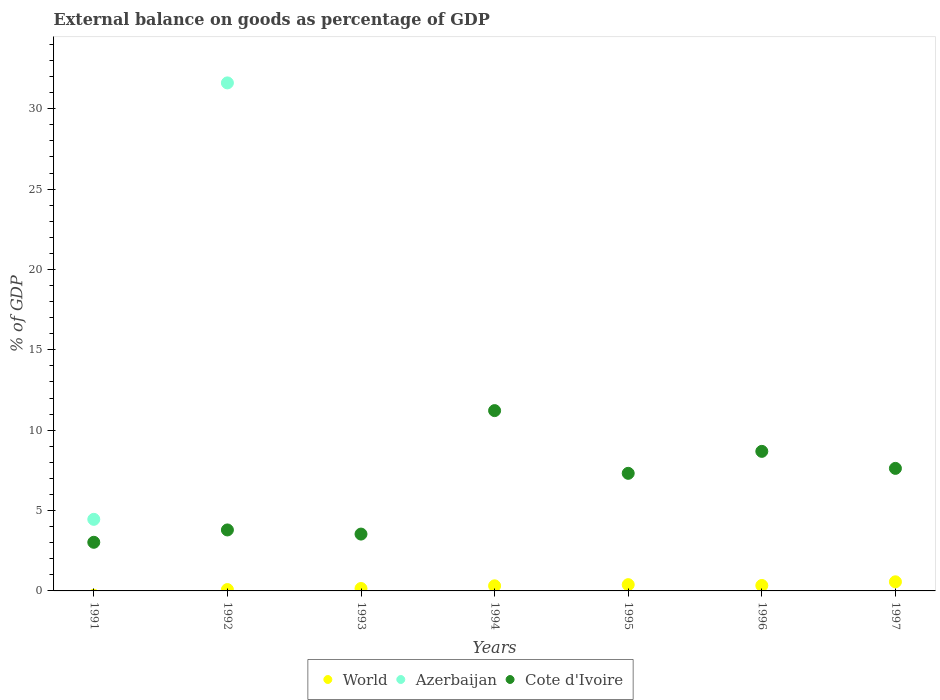What is the external balance on goods as percentage of GDP in Cote d'Ivoire in 1992?
Provide a succinct answer. 3.79. Across all years, what is the maximum external balance on goods as percentage of GDP in Cote d'Ivoire?
Give a very brief answer. 11.22. Across all years, what is the minimum external balance on goods as percentage of GDP in World?
Provide a succinct answer. 0. What is the total external balance on goods as percentage of GDP in World in the graph?
Provide a short and direct response. 1.85. What is the difference between the external balance on goods as percentage of GDP in Cote d'Ivoire in 1993 and that in 1996?
Keep it short and to the point. -5.15. What is the difference between the external balance on goods as percentage of GDP in Azerbaijan in 1994 and the external balance on goods as percentage of GDP in Cote d'Ivoire in 1997?
Make the answer very short. -7.62. What is the average external balance on goods as percentage of GDP in World per year?
Provide a short and direct response. 0.26. In the year 1992, what is the difference between the external balance on goods as percentage of GDP in Azerbaijan and external balance on goods as percentage of GDP in Cote d'Ivoire?
Your answer should be very brief. 27.81. In how many years, is the external balance on goods as percentage of GDP in Cote d'Ivoire greater than 30 %?
Ensure brevity in your answer.  0. What is the ratio of the external balance on goods as percentage of GDP in World in 1996 to that in 1997?
Keep it short and to the point. 0.6. What is the difference between the highest and the second highest external balance on goods as percentage of GDP in World?
Ensure brevity in your answer.  0.18. What is the difference between the highest and the lowest external balance on goods as percentage of GDP in Azerbaijan?
Offer a terse response. 31.61. Is the sum of the external balance on goods as percentage of GDP in World in 1993 and 1997 greater than the maximum external balance on goods as percentage of GDP in Azerbaijan across all years?
Ensure brevity in your answer.  No. Is it the case that in every year, the sum of the external balance on goods as percentage of GDP in Cote d'Ivoire and external balance on goods as percentage of GDP in Azerbaijan  is greater than the external balance on goods as percentage of GDP in World?
Give a very brief answer. Yes. Does the external balance on goods as percentage of GDP in Azerbaijan monotonically increase over the years?
Provide a succinct answer. No. Is the external balance on goods as percentage of GDP in Azerbaijan strictly greater than the external balance on goods as percentage of GDP in Cote d'Ivoire over the years?
Make the answer very short. No. Is the external balance on goods as percentage of GDP in World strictly less than the external balance on goods as percentage of GDP in Azerbaijan over the years?
Give a very brief answer. No. What is the difference between two consecutive major ticks on the Y-axis?
Keep it short and to the point. 5. Are the values on the major ticks of Y-axis written in scientific E-notation?
Give a very brief answer. No. Does the graph contain any zero values?
Give a very brief answer. Yes. Does the graph contain grids?
Your answer should be very brief. No. Where does the legend appear in the graph?
Provide a succinct answer. Bottom center. What is the title of the graph?
Give a very brief answer. External balance on goods as percentage of GDP. What is the label or title of the X-axis?
Your answer should be compact. Years. What is the label or title of the Y-axis?
Offer a terse response. % of GDP. What is the % of GDP of Azerbaijan in 1991?
Give a very brief answer. 4.45. What is the % of GDP in Cote d'Ivoire in 1991?
Ensure brevity in your answer.  3.03. What is the % of GDP in World in 1992?
Ensure brevity in your answer.  0.08. What is the % of GDP of Azerbaijan in 1992?
Provide a succinct answer. 31.61. What is the % of GDP in Cote d'Ivoire in 1992?
Your response must be concise. 3.79. What is the % of GDP in World in 1993?
Your answer should be very brief. 0.15. What is the % of GDP in Cote d'Ivoire in 1993?
Provide a succinct answer. 3.54. What is the % of GDP in World in 1994?
Provide a short and direct response. 0.32. What is the % of GDP in Cote d'Ivoire in 1994?
Your answer should be very brief. 11.22. What is the % of GDP of World in 1995?
Make the answer very short. 0.39. What is the % of GDP of Azerbaijan in 1995?
Offer a terse response. 0. What is the % of GDP in Cote d'Ivoire in 1995?
Offer a terse response. 7.32. What is the % of GDP in World in 1996?
Ensure brevity in your answer.  0.34. What is the % of GDP in Azerbaijan in 1996?
Provide a short and direct response. 0. What is the % of GDP of Cote d'Ivoire in 1996?
Your response must be concise. 8.68. What is the % of GDP of World in 1997?
Your answer should be compact. 0.57. What is the % of GDP in Azerbaijan in 1997?
Offer a very short reply. 0. What is the % of GDP of Cote d'Ivoire in 1997?
Provide a succinct answer. 7.62. Across all years, what is the maximum % of GDP in World?
Make the answer very short. 0.57. Across all years, what is the maximum % of GDP of Azerbaijan?
Offer a very short reply. 31.61. Across all years, what is the maximum % of GDP of Cote d'Ivoire?
Give a very brief answer. 11.22. Across all years, what is the minimum % of GDP in Cote d'Ivoire?
Offer a very short reply. 3.03. What is the total % of GDP of World in the graph?
Your response must be concise. 1.85. What is the total % of GDP in Azerbaijan in the graph?
Your answer should be very brief. 36.06. What is the total % of GDP of Cote d'Ivoire in the graph?
Offer a terse response. 45.2. What is the difference between the % of GDP of Azerbaijan in 1991 and that in 1992?
Offer a very short reply. -27.15. What is the difference between the % of GDP of Cote d'Ivoire in 1991 and that in 1992?
Your answer should be very brief. -0.77. What is the difference between the % of GDP of Cote d'Ivoire in 1991 and that in 1993?
Your answer should be compact. -0.51. What is the difference between the % of GDP in Cote d'Ivoire in 1991 and that in 1994?
Provide a succinct answer. -8.19. What is the difference between the % of GDP in Cote d'Ivoire in 1991 and that in 1995?
Keep it short and to the point. -4.29. What is the difference between the % of GDP in Cote d'Ivoire in 1991 and that in 1996?
Your answer should be compact. -5.66. What is the difference between the % of GDP of Cote d'Ivoire in 1991 and that in 1997?
Your answer should be very brief. -4.6. What is the difference between the % of GDP of World in 1992 and that in 1993?
Your response must be concise. -0.07. What is the difference between the % of GDP in Cote d'Ivoire in 1992 and that in 1993?
Give a very brief answer. 0.26. What is the difference between the % of GDP in World in 1992 and that in 1994?
Make the answer very short. -0.23. What is the difference between the % of GDP in Cote d'Ivoire in 1992 and that in 1994?
Your response must be concise. -7.42. What is the difference between the % of GDP in World in 1992 and that in 1995?
Your answer should be very brief. -0.31. What is the difference between the % of GDP in Cote d'Ivoire in 1992 and that in 1995?
Offer a very short reply. -3.52. What is the difference between the % of GDP of World in 1992 and that in 1996?
Offer a terse response. -0.25. What is the difference between the % of GDP of Cote d'Ivoire in 1992 and that in 1996?
Make the answer very short. -4.89. What is the difference between the % of GDP of World in 1992 and that in 1997?
Provide a succinct answer. -0.48. What is the difference between the % of GDP in Cote d'Ivoire in 1992 and that in 1997?
Your answer should be compact. -3.83. What is the difference between the % of GDP in World in 1993 and that in 1994?
Your answer should be compact. -0.17. What is the difference between the % of GDP of Cote d'Ivoire in 1993 and that in 1994?
Your response must be concise. -7.68. What is the difference between the % of GDP in World in 1993 and that in 1995?
Make the answer very short. -0.24. What is the difference between the % of GDP in Cote d'Ivoire in 1993 and that in 1995?
Make the answer very short. -3.78. What is the difference between the % of GDP of World in 1993 and that in 1996?
Your answer should be very brief. -0.19. What is the difference between the % of GDP in Cote d'Ivoire in 1993 and that in 1996?
Make the answer very short. -5.15. What is the difference between the % of GDP in World in 1993 and that in 1997?
Offer a very short reply. -0.42. What is the difference between the % of GDP in Cote d'Ivoire in 1993 and that in 1997?
Offer a terse response. -4.09. What is the difference between the % of GDP in World in 1994 and that in 1995?
Give a very brief answer. -0.07. What is the difference between the % of GDP of Cote d'Ivoire in 1994 and that in 1995?
Give a very brief answer. 3.9. What is the difference between the % of GDP of World in 1994 and that in 1996?
Ensure brevity in your answer.  -0.02. What is the difference between the % of GDP in Cote d'Ivoire in 1994 and that in 1996?
Provide a succinct answer. 2.54. What is the difference between the % of GDP of World in 1994 and that in 1997?
Keep it short and to the point. -0.25. What is the difference between the % of GDP of Cote d'Ivoire in 1994 and that in 1997?
Offer a very short reply. 3.59. What is the difference between the % of GDP in World in 1995 and that in 1996?
Offer a very short reply. 0.05. What is the difference between the % of GDP of Cote d'Ivoire in 1995 and that in 1996?
Make the answer very short. -1.37. What is the difference between the % of GDP in World in 1995 and that in 1997?
Offer a terse response. -0.18. What is the difference between the % of GDP in Cote d'Ivoire in 1995 and that in 1997?
Offer a very short reply. -0.31. What is the difference between the % of GDP of World in 1996 and that in 1997?
Offer a very short reply. -0.23. What is the difference between the % of GDP in Cote d'Ivoire in 1996 and that in 1997?
Provide a short and direct response. 1.06. What is the difference between the % of GDP of Azerbaijan in 1991 and the % of GDP of Cote d'Ivoire in 1992?
Your answer should be very brief. 0.66. What is the difference between the % of GDP of Azerbaijan in 1991 and the % of GDP of Cote d'Ivoire in 1993?
Provide a succinct answer. 0.92. What is the difference between the % of GDP of Azerbaijan in 1991 and the % of GDP of Cote d'Ivoire in 1994?
Give a very brief answer. -6.76. What is the difference between the % of GDP in Azerbaijan in 1991 and the % of GDP in Cote d'Ivoire in 1995?
Provide a short and direct response. -2.86. What is the difference between the % of GDP of Azerbaijan in 1991 and the % of GDP of Cote d'Ivoire in 1996?
Offer a terse response. -4.23. What is the difference between the % of GDP in Azerbaijan in 1991 and the % of GDP in Cote d'Ivoire in 1997?
Provide a short and direct response. -3.17. What is the difference between the % of GDP of World in 1992 and the % of GDP of Cote d'Ivoire in 1993?
Provide a short and direct response. -3.45. What is the difference between the % of GDP in Azerbaijan in 1992 and the % of GDP in Cote d'Ivoire in 1993?
Your answer should be very brief. 28.07. What is the difference between the % of GDP of World in 1992 and the % of GDP of Cote d'Ivoire in 1994?
Provide a short and direct response. -11.13. What is the difference between the % of GDP of Azerbaijan in 1992 and the % of GDP of Cote d'Ivoire in 1994?
Provide a short and direct response. 20.39. What is the difference between the % of GDP in World in 1992 and the % of GDP in Cote d'Ivoire in 1995?
Ensure brevity in your answer.  -7.23. What is the difference between the % of GDP in Azerbaijan in 1992 and the % of GDP in Cote d'Ivoire in 1995?
Your answer should be very brief. 24.29. What is the difference between the % of GDP in World in 1992 and the % of GDP in Cote d'Ivoire in 1996?
Your answer should be very brief. -8.6. What is the difference between the % of GDP in Azerbaijan in 1992 and the % of GDP in Cote d'Ivoire in 1996?
Your response must be concise. 22.92. What is the difference between the % of GDP in World in 1992 and the % of GDP in Cote d'Ivoire in 1997?
Your answer should be very brief. -7.54. What is the difference between the % of GDP of Azerbaijan in 1992 and the % of GDP of Cote d'Ivoire in 1997?
Give a very brief answer. 23.98. What is the difference between the % of GDP in World in 1993 and the % of GDP in Cote d'Ivoire in 1994?
Make the answer very short. -11.07. What is the difference between the % of GDP in World in 1993 and the % of GDP in Cote d'Ivoire in 1995?
Ensure brevity in your answer.  -7.17. What is the difference between the % of GDP of World in 1993 and the % of GDP of Cote d'Ivoire in 1996?
Your response must be concise. -8.53. What is the difference between the % of GDP of World in 1993 and the % of GDP of Cote d'Ivoire in 1997?
Make the answer very short. -7.47. What is the difference between the % of GDP in World in 1994 and the % of GDP in Cote d'Ivoire in 1995?
Keep it short and to the point. -7. What is the difference between the % of GDP in World in 1994 and the % of GDP in Cote d'Ivoire in 1996?
Your response must be concise. -8.37. What is the difference between the % of GDP of World in 1994 and the % of GDP of Cote d'Ivoire in 1997?
Offer a very short reply. -7.31. What is the difference between the % of GDP of World in 1995 and the % of GDP of Cote d'Ivoire in 1996?
Keep it short and to the point. -8.29. What is the difference between the % of GDP of World in 1995 and the % of GDP of Cote d'Ivoire in 1997?
Give a very brief answer. -7.23. What is the difference between the % of GDP of World in 1996 and the % of GDP of Cote d'Ivoire in 1997?
Provide a succinct answer. -7.29. What is the average % of GDP of World per year?
Your answer should be very brief. 0.26. What is the average % of GDP in Azerbaijan per year?
Your answer should be very brief. 5.15. What is the average % of GDP in Cote d'Ivoire per year?
Give a very brief answer. 6.46. In the year 1991, what is the difference between the % of GDP of Azerbaijan and % of GDP of Cote d'Ivoire?
Your answer should be compact. 1.43. In the year 1992, what is the difference between the % of GDP of World and % of GDP of Azerbaijan?
Provide a succinct answer. -31.52. In the year 1992, what is the difference between the % of GDP in World and % of GDP in Cote d'Ivoire?
Make the answer very short. -3.71. In the year 1992, what is the difference between the % of GDP in Azerbaijan and % of GDP in Cote d'Ivoire?
Provide a short and direct response. 27.81. In the year 1993, what is the difference between the % of GDP of World and % of GDP of Cote d'Ivoire?
Make the answer very short. -3.39. In the year 1994, what is the difference between the % of GDP in World and % of GDP in Cote d'Ivoire?
Your response must be concise. -10.9. In the year 1995, what is the difference between the % of GDP in World and % of GDP in Cote d'Ivoire?
Your response must be concise. -6.93. In the year 1996, what is the difference between the % of GDP of World and % of GDP of Cote d'Ivoire?
Your answer should be very brief. -8.34. In the year 1997, what is the difference between the % of GDP in World and % of GDP in Cote d'Ivoire?
Make the answer very short. -7.06. What is the ratio of the % of GDP in Azerbaijan in 1991 to that in 1992?
Give a very brief answer. 0.14. What is the ratio of the % of GDP in Cote d'Ivoire in 1991 to that in 1992?
Give a very brief answer. 0.8. What is the ratio of the % of GDP in Cote d'Ivoire in 1991 to that in 1993?
Make the answer very short. 0.86. What is the ratio of the % of GDP in Cote d'Ivoire in 1991 to that in 1994?
Provide a succinct answer. 0.27. What is the ratio of the % of GDP in Cote d'Ivoire in 1991 to that in 1995?
Offer a very short reply. 0.41. What is the ratio of the % of GDP of Cote d'Ivoire in 1991 to that in 1996?
Make the answer very short. 0.35. What is the ratio of the % of GDP in Cote d'Ivoire in 1991 to that in 1997?
Your response must be concise. 0.4. What is the ratio of the % of GDP in World in 1992 to that in 1993?
Provide a succinct answer. 0.56. What is the ratio of the % of GDP of Cote d'Ivoire in 1992 to that in 1993?
Your response must be concise. 1.07. What is the ratio of the % of GDP in World in 1992 to that in 1994?
Ensure brevity in your answer.  0.27. What is the ratio of the % of GDP in Cote d'Ivoire in 1992 to that in 1994?
Provide a short and direct response. 0.34. What is the ratio of the % of GDP of World in 1992 to that in 1995?
Provide a succinct answer. 0.22. What is the ratio of the % of GDP in Cote d'Ivoire in 1992 to that in 1995?
Provide a short and direct response. 0.52. What is the ratio of the % of GDP of World in 1992 to that in 1996?
Provide a short and direct response. 0.25. What is the ratio of the % of GDP of Cote d'Ivoire in 1992 to that in 1996?
Your response must be concise. 0.44. What is the ratio of the % of GDP in World in 1992 to that in 1997?
Your response must be concise. 0.15. What is the ratio of the % of GDP of Cote d'Ivoire in 1992 to that in 1997?
Make the answer very short. 0.5. What is the ratio of the % of GDP of World in 1993 to that in 1994?
Make the answer very short. 0.47. What is the ratio of the % of GDP in Cote d'Ivoire in 1993 to that in 1994?
Ensure brevity in your answer.  0.32. What is the ratio of the % of GDP of World in 1993 to that in 1995?
Your answer should be very brief. 0.39. What is the ratio of the % of GDP of Cote d'Ivoire in 1993 to that in 1995?
Give a very brief answer. 0.48. What is the ratio of the % of GDP in World in 1993 to that in 1996?
Ensure brevity in your answer.  0.45. What is the ratio of the % of GDP of Cote d'Ivoire in 1993 to that in 1996?
Offer a very short reply. 0.41. What is the ratio of the % of GDP of World in 1993 to that in 1997?
Your answer should be very brief. 0.27. What is the ratio of the % of GDP in Cote d'Ivoire in 1993 to that in 1997?
Make the answer very short. 0.46. What is the ratio of the % of GDP in World in 1994 to that in 1995?
Provide a succinct answer. 0.81. What is the ratio of the % of GDP of Cote d'Ivoire in 1994 to that in 1995?
Give a very brief answer. 1.53. What is the ratio of the % of GDP of World in 1994 to that in 1996?
Make the answer very short. 0.94. What is the ratio of the % of GDP of Cote d'Ivoire in 1994 to that in 1996?
Provide a short and direct response. 1.29. What is the ratio of the % of GDP of World in 1994 to that in 1997?
Give a very brief answer. 0.56. What is the ratio of the % of GDP in Cote d'Ivoire in 1994 to that in 1997?
Offer a terse response. 1.47. What is the ratio of the % of GDP in World in 1995 to that in 1996?
Your answer should be very brief. 1.15. What is the ratio of the % of GDP of Cote d'Ivoire in 1995 to that in 1996?
Make the answer very short. 0.84. What is the ratio of the % of GDP of World in 1995 to that in 1997?
Offer a terse response. 0.69. What is the ratio of the % of GDP of Cote d'Ivoire in 1995 to that in 1997?
Provide a short and direct response. 0.96. What is the ratio of the % of GDP in World in 1996 to that in 1997?
Offer a terse response. 0.6. What is the ratio of the % of GDP in Cote d'Ivoire in 1996 to that in 1997?
Keep it short and to the point. 1.14. What is the difference between the highest and the second highest % of GDP in World?
Offer a terse response. 0.18. What is the difference between the highest and the second highest % of GDP of Cote d'Ivoire?
Ensure brevity in your answer.  2.54. What is the difference between the highest and the lowest % of GDP of World?
Your answer should be very brief. 0.57. What is the difference between the highest and the lowest % of GDP in Azerbaijan?
Offer a very short reply. 31.61. What is the difference between the highest and the lowest % of GDP of Cote d'Ivoire?
Your answer should be compact. 8.19. 